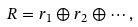Convert formula to latex. <formula><loc_0><loc_0><loc_500><loc_500>R = r _ { 1 } \oplus r _ { 2 } \oplus \cdots ,</formula> 